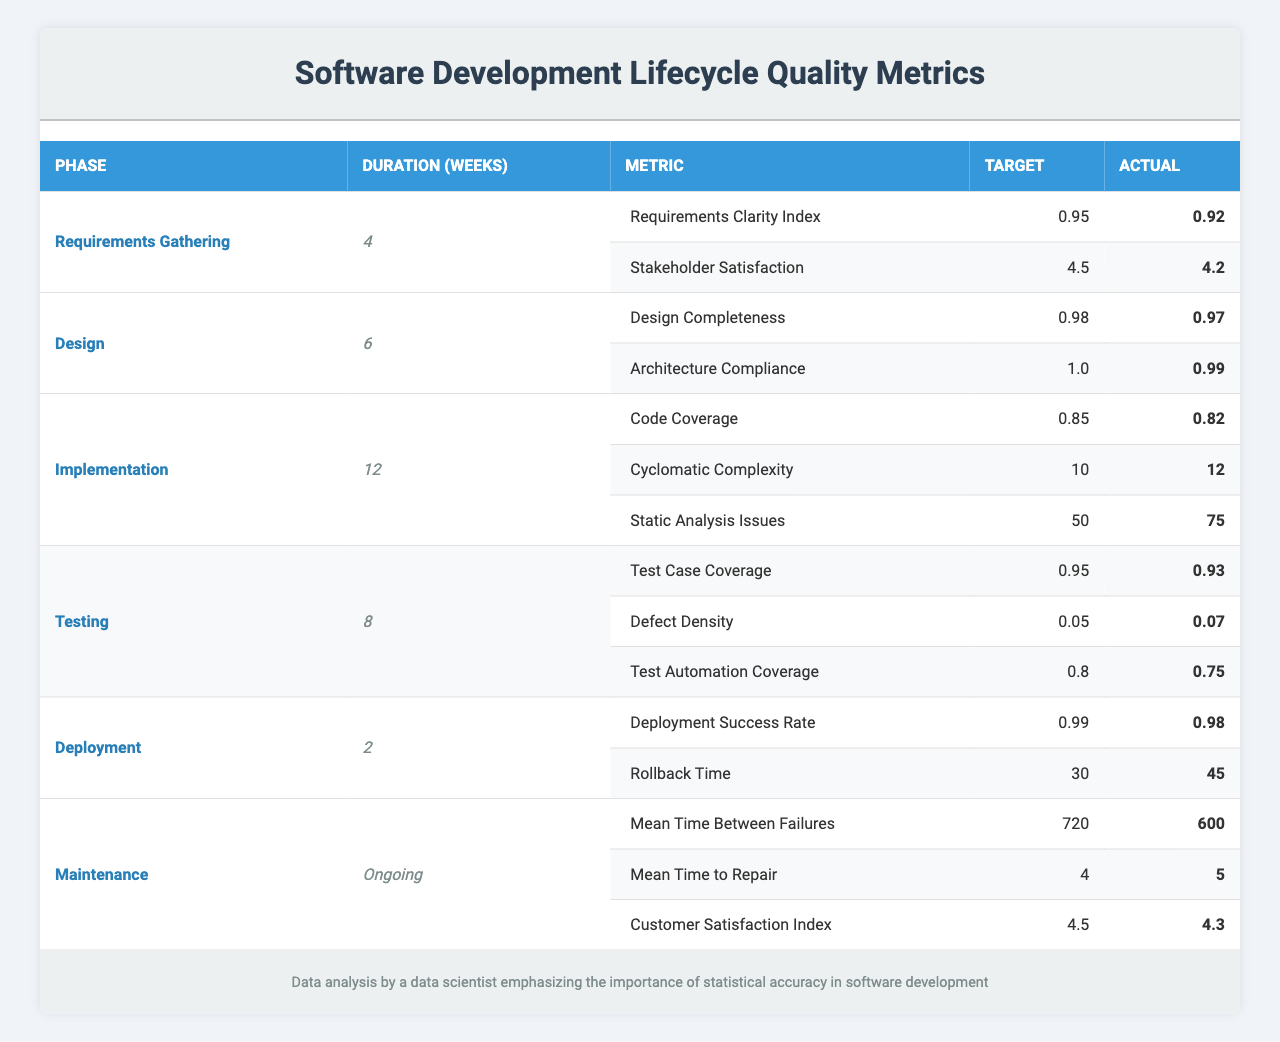What is the duration of the Testing phase? The table lists the duration for each phase. The duration for the Testing phase is provided in the corresponding row, which shows it lasts for 8 weeks.
Answer: 8 weeks What is the actual Requirements Clarity Index in Requirements Gathering? The table includes a specific metric for Requirements Gathering. The Actual value for the Requirements Clarity Index is listed as 0.92.
Answer: 0.92 How many quality metrics are there in the Implementation phase? The Implementation phase has three quality metrics listed in the table, which can be counted from the respective rows.
Answer: 3 Is the actual Code Coverage greater than the target? The target for Code Coverage is 0.85, and the actual value is 0.82. Since 0.82 is less than 0.85, the actual Code Coverage is not greater than the target.
Answer: No What is the target for the Deployment Success Rate? The target for Deployment Success Rate is explicitly stated in the Deployment phase row of the table as 0.99.
Answer: 0.99 If the Mean Time Between Failures is 720 and the actual is 600, what is the difference? To find the difference, subtract the Actual value (600) from the Target (720): 720 - 600 = 120.
Answer: 120 Which phase has the highest target for quality metrics? A review of the quality metrics shows that the highest target is 1.0 for Architecture Compliance in the Design phase, as no other metric exceeds this value.
Answer: Design phase (Architecture Compliance) What is the average actual value of all quality metrics in the Maintenance phase? The actual values for the Maintenance phase metrics are 600, 5, and 4.3. To get the average, calculate (600 + 5 + 4.3) / 3 = 203.43.
Answer: 203.43 What is the total duration of all the phases combined, excluding Maintenance? Adding the durations together for each phase (4 + 6 + 12 + 8 + 2) results in 32 weeks, excluding Maintenance which is ongoing.
Answer: 32 weeks Was the actual Defect Density higher than the target in the Testing phase? The target value for Defect Density is 0.05, and the actual value is 0.07. Since 0.07 is greater than 0.05, the actual Defect Density was indeed higher than the target.
Answer: Yes What percentage of metrics in the Implementation phase met or exceeded their targets? The Implementation phase has three metrics: Code Coverage (0.82 < 0.85), Cyclomatic Complexity (12 > 10), and Static Analysis Issues (75 > 50). Only Cyclomatic Complexity meets the target, so the percentage is (1/3)*100 = 33.33%.
Answer: 33.33% 